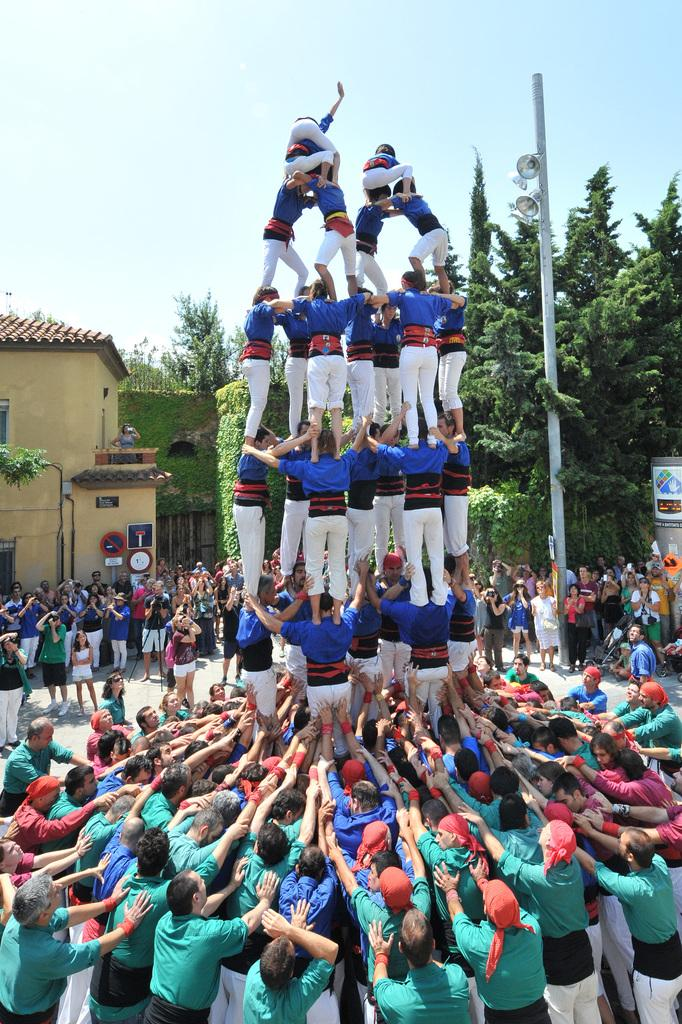How many people are in the image? There is a group of people in the image, but the exact number is not specified. What are the people in the image doing? The people are standing in the image. What can be seen in the background of the image? There are houses, trees, poles, and speakers in the background of the image. What is visible at the top of the image? The sky is visible at the top of the image. Can you see any steam coming from the people in the image? There is no steam visible in the image. Are the people swimming in the image? The people are standing, not swimming, in the image. 